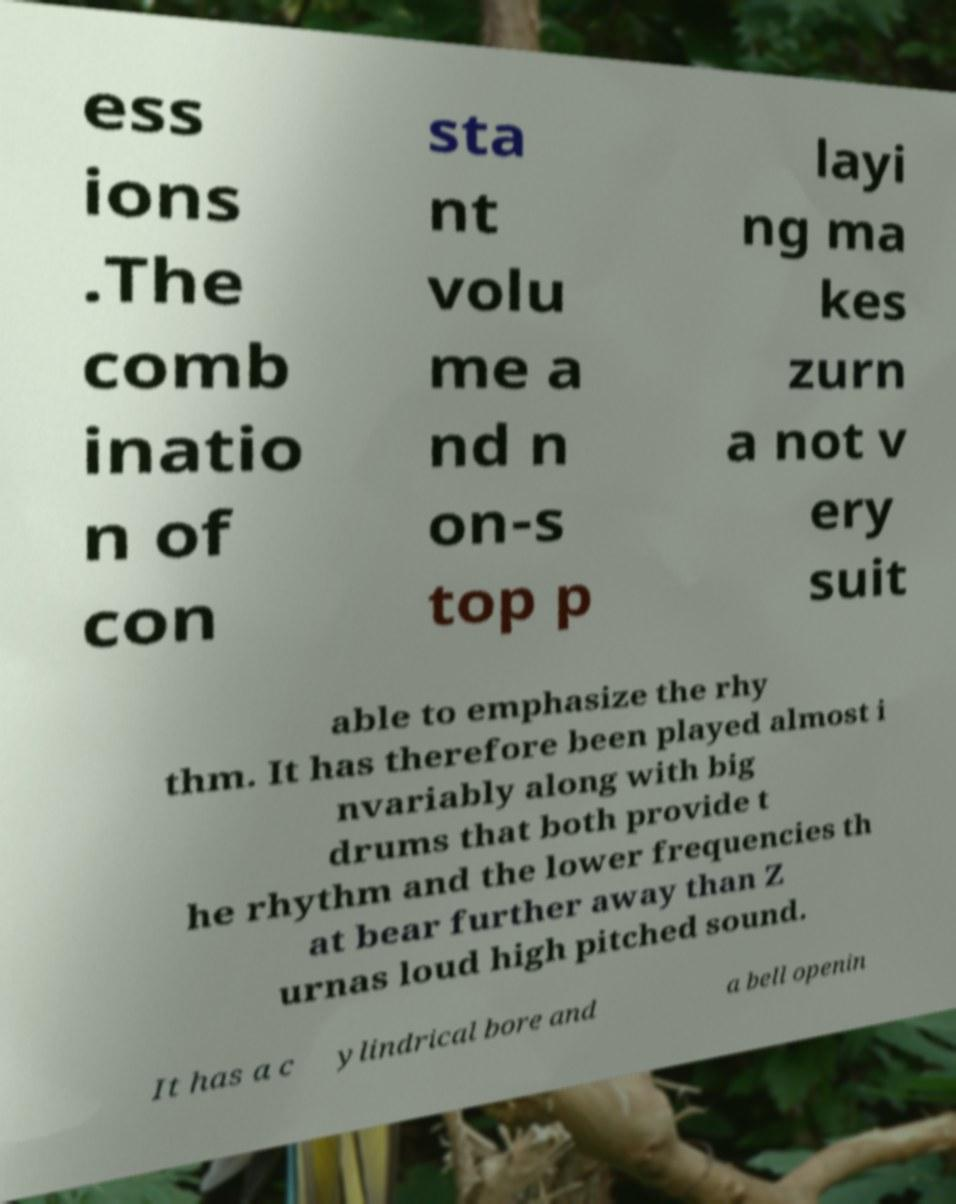Could you assist in decoding the text presented in this image and type it out clearly? ess ions .The comb inatio n of con sta nt volu me a nd n on-s top p layi ng ma kes zurn a not v ery suit able to emphasize the rhy thm. It has therefore been played almost i nvariably along with big drums that both provide t he rhythm and the lower frequencies th at bear further away than Z urnas loud high pitched sound. It has a c ylindrical bore and a bell openin 